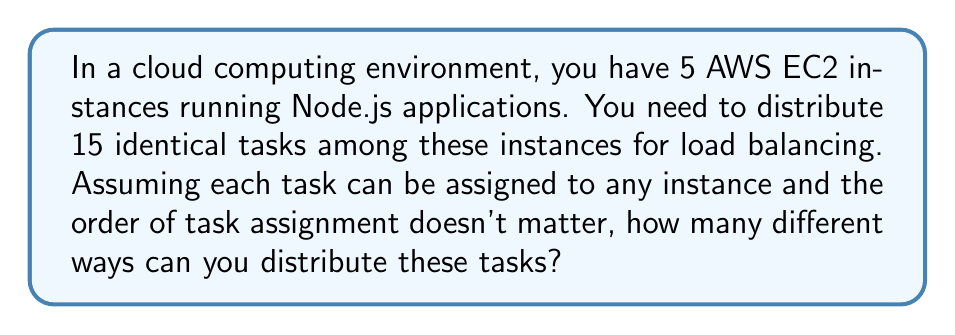Solve this math problem. Let's approach this step-by-step:

1) This problem can be modeled as a stars and bars problem in combinatorics. We have 15 identical tasks (stars) and 5 EC2 instances (bars).

2) The formula for stars and bars is:

   $${n+k-1 \choose k-1}$$

   Where $n$ is the number of identical objects (tasks) and $k$ is the number of bins (EC2 instances).

3) In this case, $n = 15$ and $k = 5$.

4) Plugging these values into the formula:

   $${15+5-1 \choose 5-1} = {19 \choose 4}$$

5) Expand this combination:

   $$\frac{19!}{4!(19-4)!} = \frac{19!}{4!15!}$$

6) Calculate:
   
   $$\frac{19 \cdot 18 \cdot 17 \cdot 16}{4 \cdot 3 \cdot 2 \cdot 1} = 3876$$

Therefore, there are 3876 different ways to distribute the tasks among the EC2 instances.
Answer: 3876 